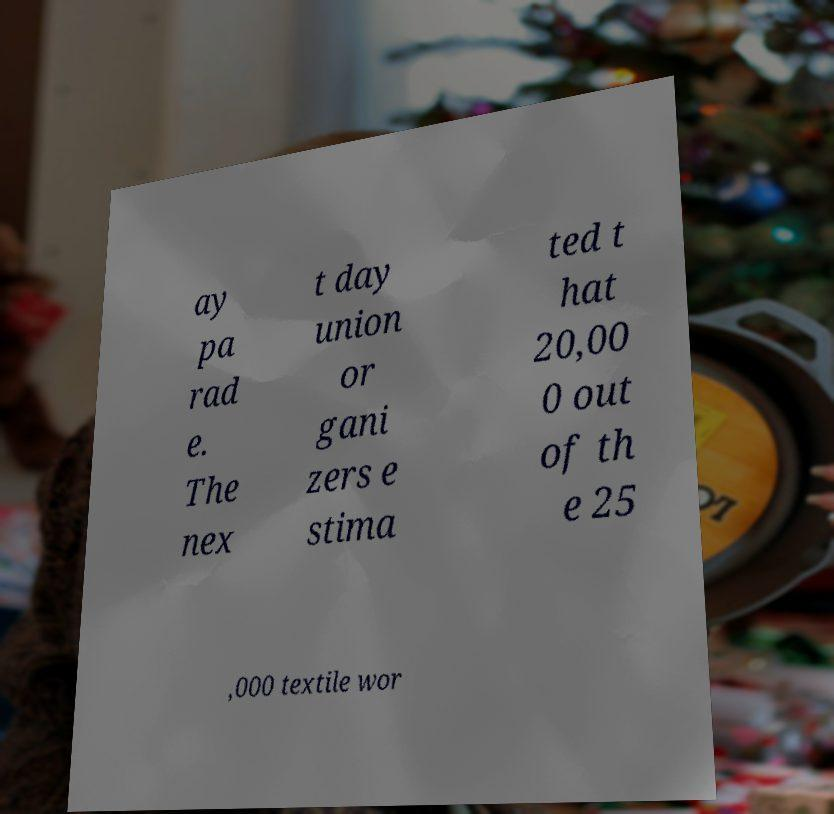Can you read and provide the text displayed in the image?This photo seems to have some interesting text. Can you extract and type it out for me? ay pa rad e. The nex t day union or gani zers e stima ted t hat 20,00 0 out of th e 25 ,000 textile wor 